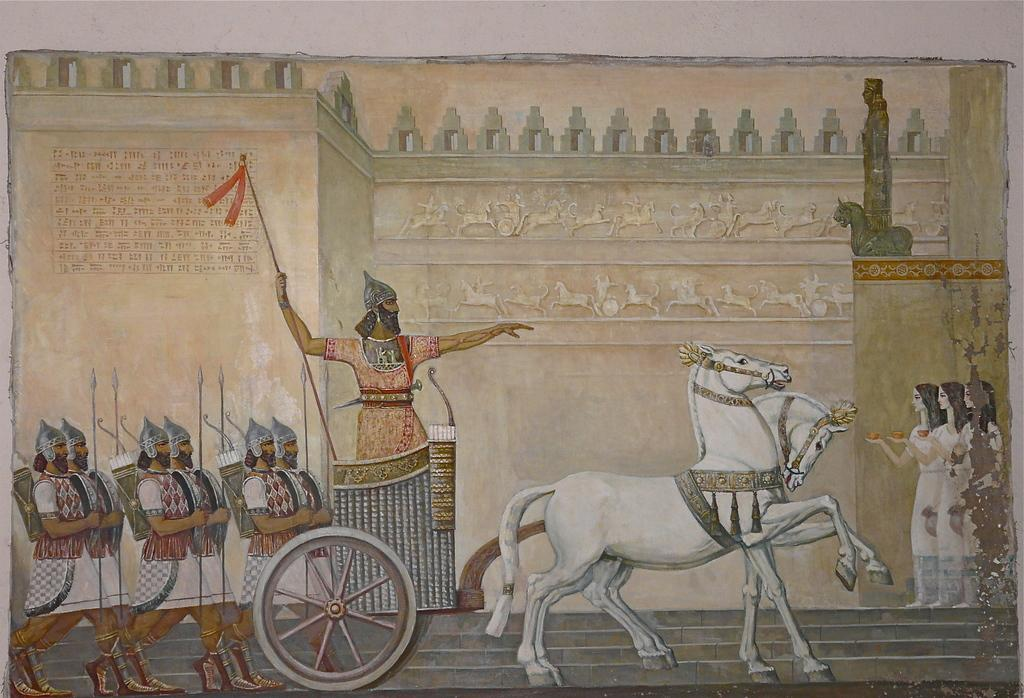What type of artwork is depicted in the image? The image is a painting. Can you see any cactus plants in the painting? There is no information provided about the content of the painting, so it cannot be determined if there are any cactus plants present. 